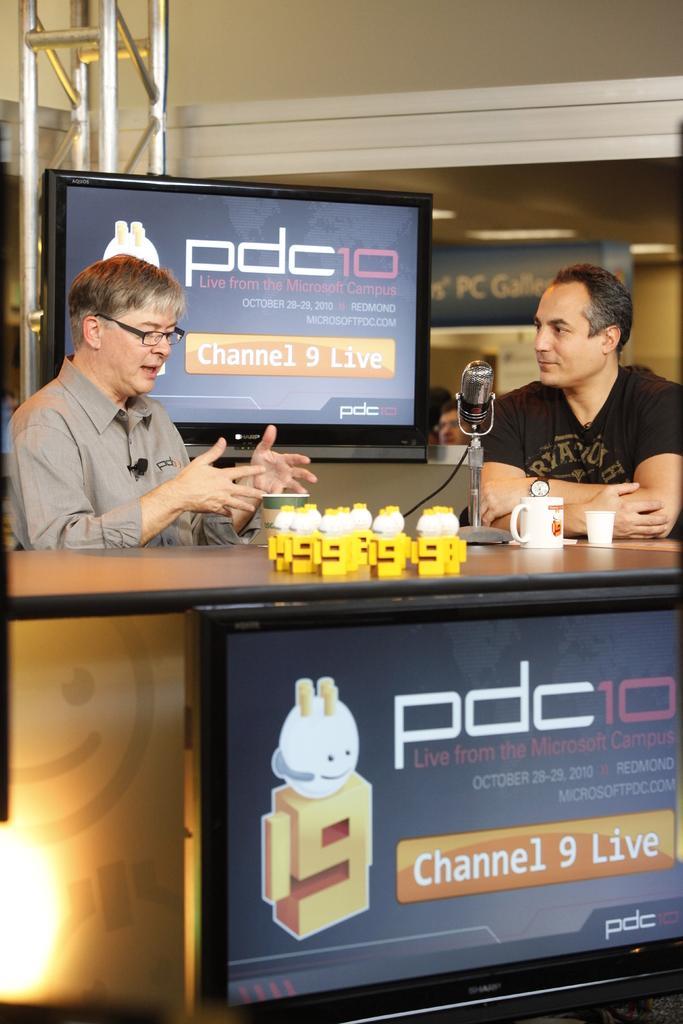How would you summarize this image in a sentence or two? In this image we can see two men are sitting at the table and on the table we can see objects, cups and a mic on a stand. At the bottom we can see a TV. In the background we can see a TV, poles, hoardings, wall, lights on the ceiling and few persons. 